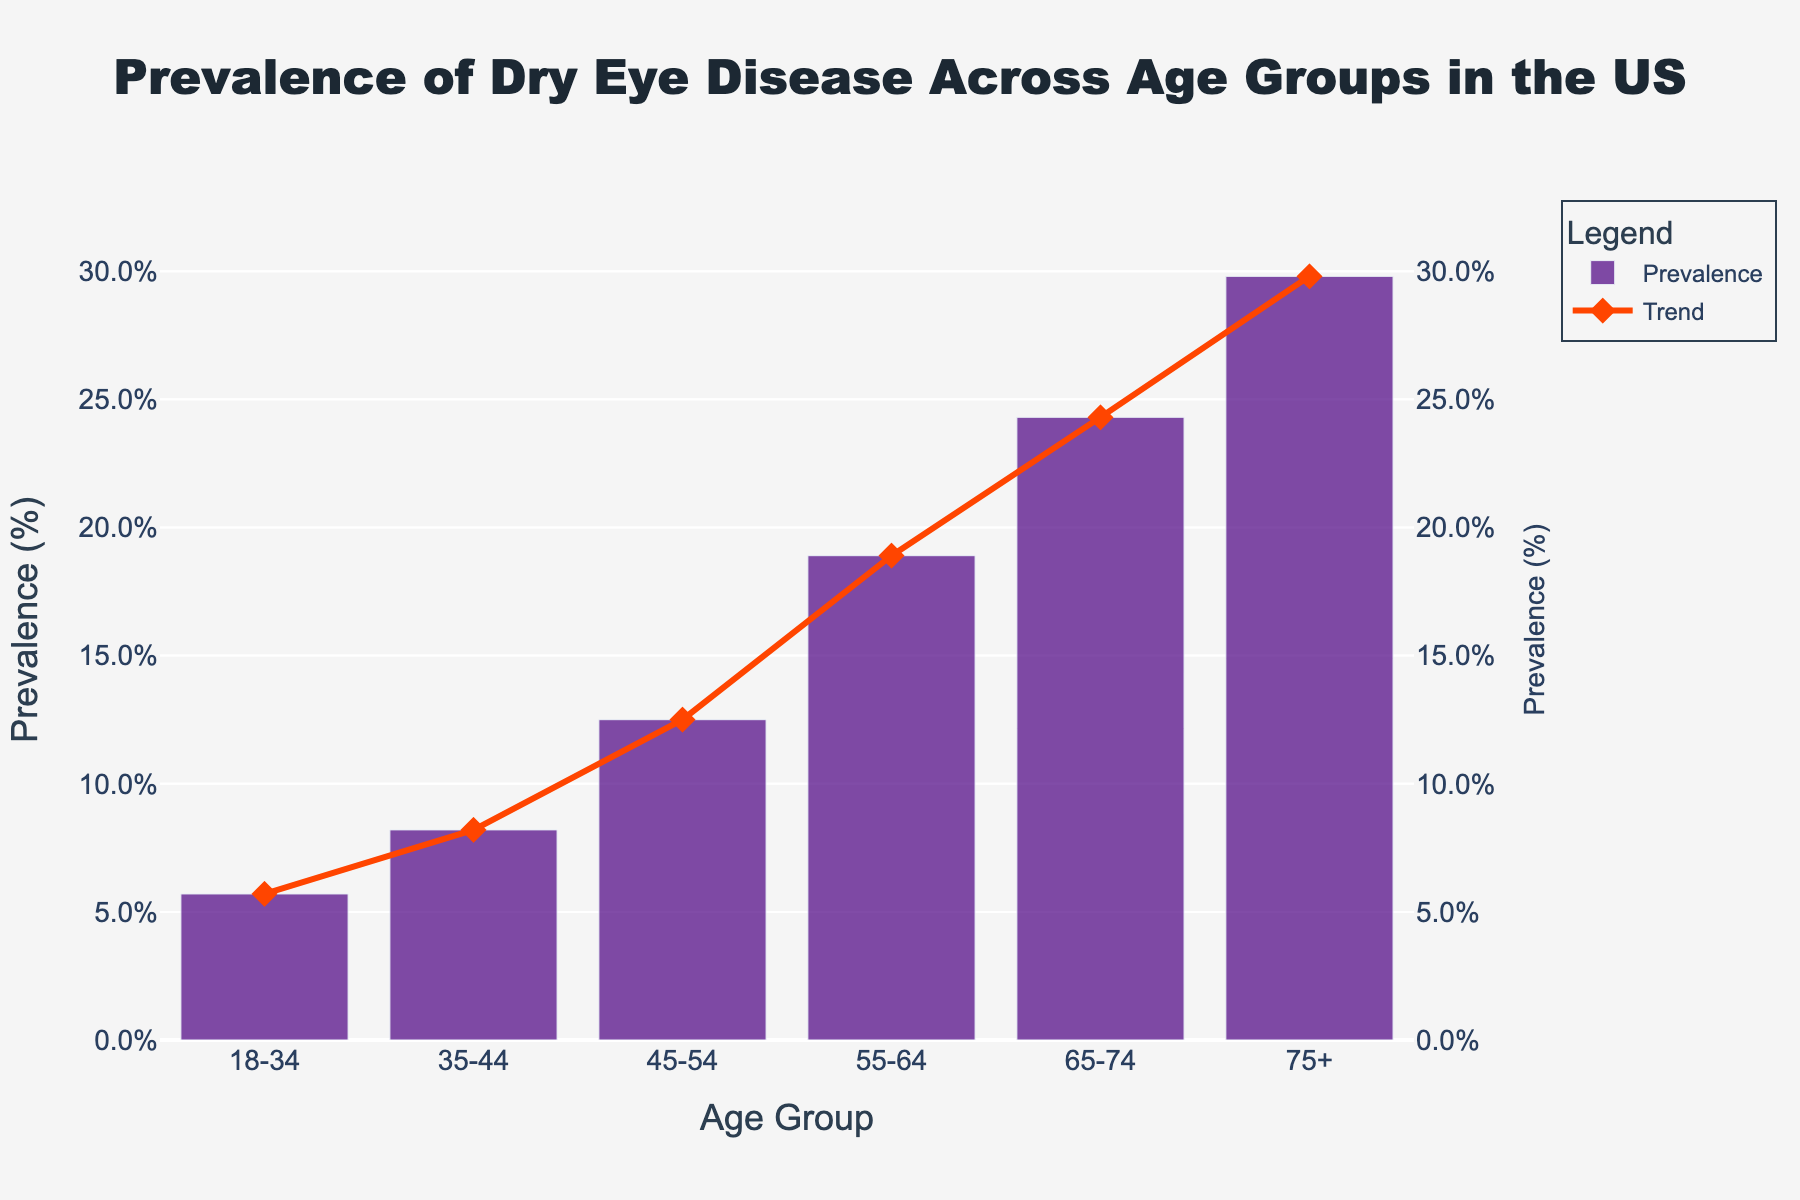What is the age group with the highest prevalence of dry eye disease? The age group with the highest prevalence can be identified by looking at the tallest bar or highest point in the line on the graph. The "75+" age group has the highest prevalence value.
Answer: 75+ Which age group has the lowest prevalence of dry eye disease? The age group with the lowest prevalence can be identified by looking at the shortest bar or lowest point in the line on the graph. The "18-34" age group has the lowest prevalence value.
Answer: 18-34 By how much does the prevalence of dry eye disease increase from the 18-34 age group to the 75+ age group? Subtract the prevalence value of the 18-34 age group from the prevalence value of the 75+ age group: 29.8% - 5.7% = 24.1%.
Answer: 24.1% Which age group has a prevalence just below 20%? Looking at the bars or the points on the line, the "55-64" age group has a prevalence of 18.9%, which is just below 20%.
Answer: 55-64 What is the average prevalence of dry eye disease across all age groups? Sum the prevalence values and divide by the number of age groups: (5.7 + 8.2 + 12.5 + 18.9 + 24.3 + 29.8) / 6 = 16.57%.
Answer: 16.57% Is there evidence of any age group where the prevalence of dry eye disease increases significantly? Examine the differences between subsequent age groups. The prevalence increases most significantly from the "45-54" age group (12.5%) to the "55-64" age group (18.9%), a difference of 6.4%.
Answer: Yes, 45-54 to 55-64 If the prevalence in the "65-74" age group is combined with that of the "75+" age group, what is the combined prevalence percentage? Add the prevalence of "65-74" and "75+" age groups: 24.3% + 29.8% = 54.1%.
Answer: 54.1% By what factor does the prevalence increase from the "35-44" age group to the "75+" age group? Divide the prevalence of the "75+" age group by the prevalence of the "35-44" age group: 29.8 / 8.2 ≈ 3.63.
Answer: 3.63 Is the prevalence of dry eye disease higher in the "55-64" age group or the "65-74" age group, and by how much? Subtract the prevalence value of the "55-64" age group from the "65-74" age group: 24.3% - 18.9% = 5.4%.
Answer: 65-74 by 5.4% What is the average annual increase in prevalence from the "18-34" age group to the "75+" age group? Calculate the difference between the "18-34" and "75+" age groups' prevalence, then divide by the number of age intervals (5): (29.8% - 5.7%) / 5 = 4.82% per interval.
Answer: 4.82% per interval 